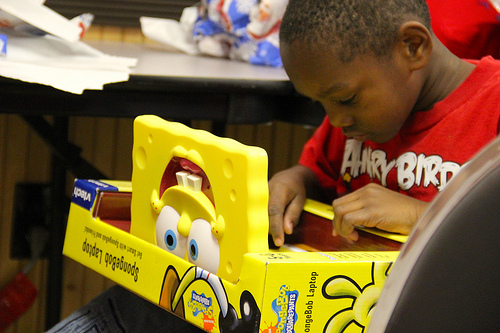<image>
Is there a kid above the toy? No. The kid is not positioned above the toy. The vertical arrangement shows a different relationship. 